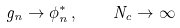<formula> <loc_0><loc_0><loc_500><loc_500>g _ { n } \rightarrow \phi _ { n } ^ { \ast } \, , \quad N _ { c } \rightarrow \infty</formula> 